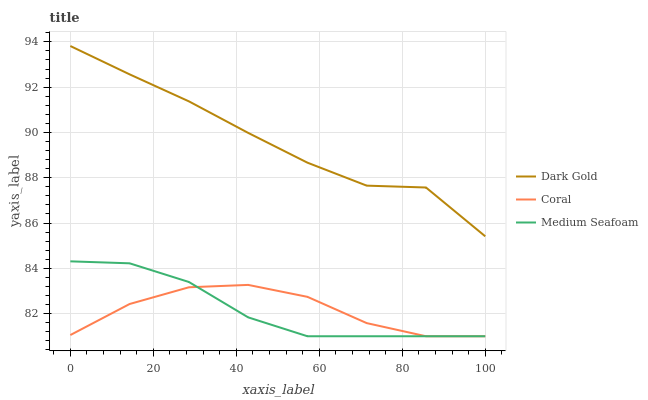Does Dark Gold have the minimum area under the curve?
Answer yes or no. No. Does Medium Seafoam have the maximum area under the curve?
Answer yes or no. No. Is Dark Gold the smoothest?
Answer yes or no. No. Is Dark Gold the roughest?
Answer yes or no. No. Does Dark Gold have the lowest value?
Answer yes or no. No. Does Medium Seafoam have the highest value?
Answer yes or no. No. Is Medium Seafoam less than Dark Gold?
Answer yes or no. Yes. Is Dark Gold greater than Medium Seafoam?
Answer yes or no. Yes. Does Medium Seafoam intersect Dark Gold?
Answer yes or no. No. 